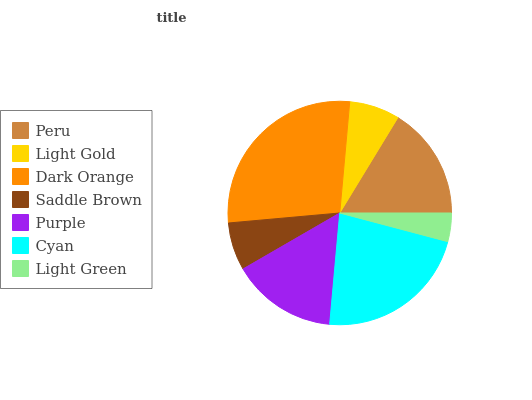Is Light Green the minimum?
Answer yes or no. Yes. Is Dark Orange the maximum?
Answer yes or no. Yes. Is Light Gold the minimum?
Answer yes or no. No. Is Light Gold the maximum?
Answer yes or no. No. Is Peru greater than Light Gold?
Answer yes or no. Yes. Is Light Gold less than Peru?
Answer yes or no. Yes. Is Light Gold greater than Peru?
Answer yes or no. No. Is Peru less than Light Gold?
Answer yes or no. No. Is Purple the high median?
Answer yes or no. Yes. Is Purple the low median?
Answer yes or no. Yes. Is Peru the high median?
Answer yes or no. No. Is Light Gold the low median?
Answer yes or no. No. 